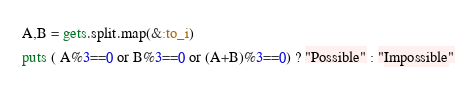Convert code to text. <code><loc_0><loc_0><loc_500><loc_500><_Ruby_>A,B = gets.split.map(&:to_i)
puts ( A%3==0 or B%3==0 or (A+B)%3==0) ? "Possible" : "Impossible"</code> 